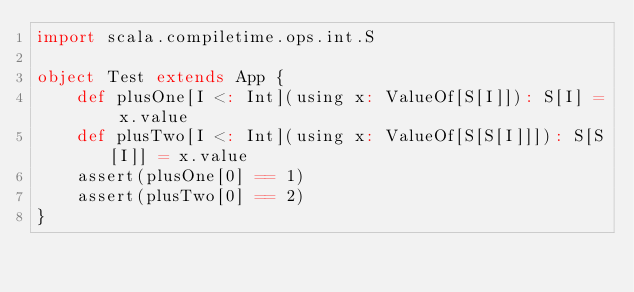<code> <loc_0><loc_0><loc_500><loc_500><_Scala_>import scala.compiletime.ops.int.S

object Test extends App {
    def plusOne[I <: Int](using x: ValueOf[S[I]]): S[I] = x.value
    def plusTwo[I <: Int](using x: ValueOf[S[S[I]]]): S[S[I]] = x.value
    assert(plusOne[0] == 1)
    assert(plusTwo[0] == 2)
}
</code> 